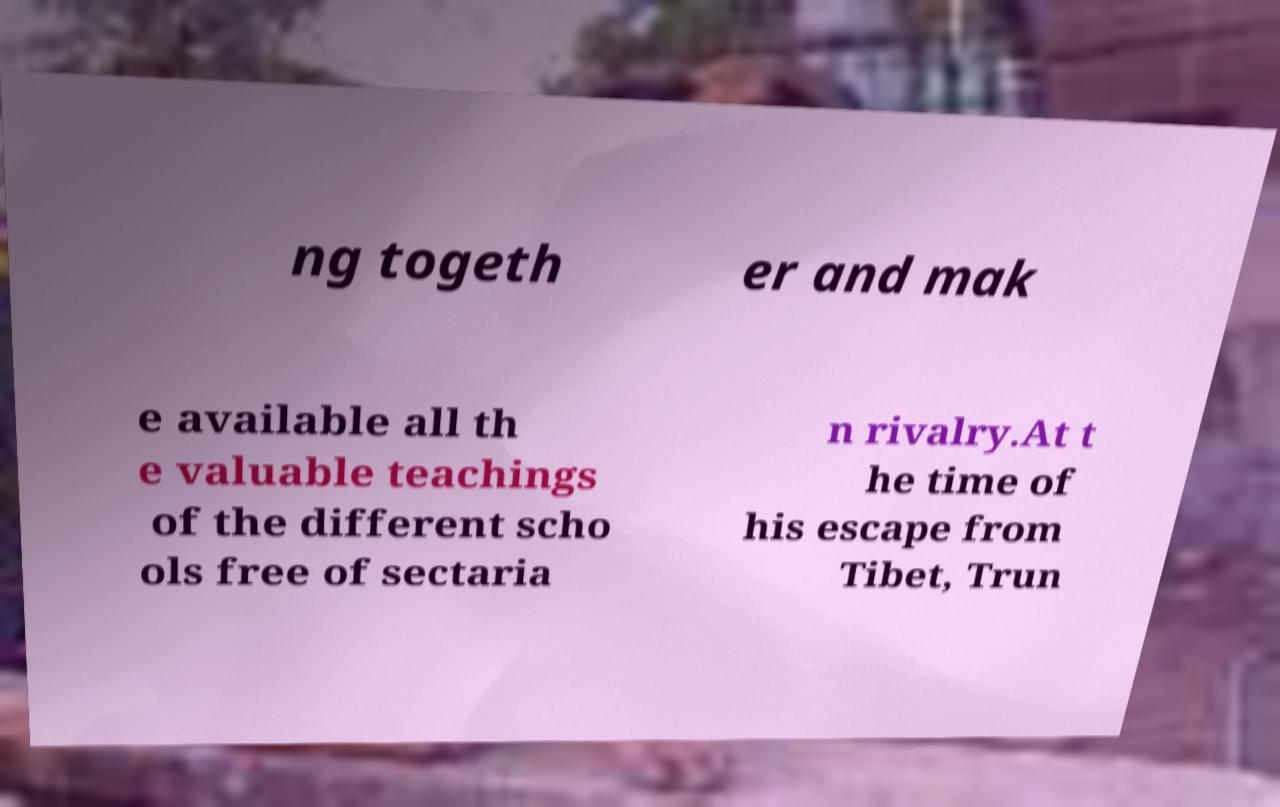There's text embedded in this image that I need extracted. Can you transcribe it verbatim? ng togeth er and mak e available all th e valuable teachings of the different scho ols free of sectaria n rivalry.At t he time of his escape from Tibet, Trun 